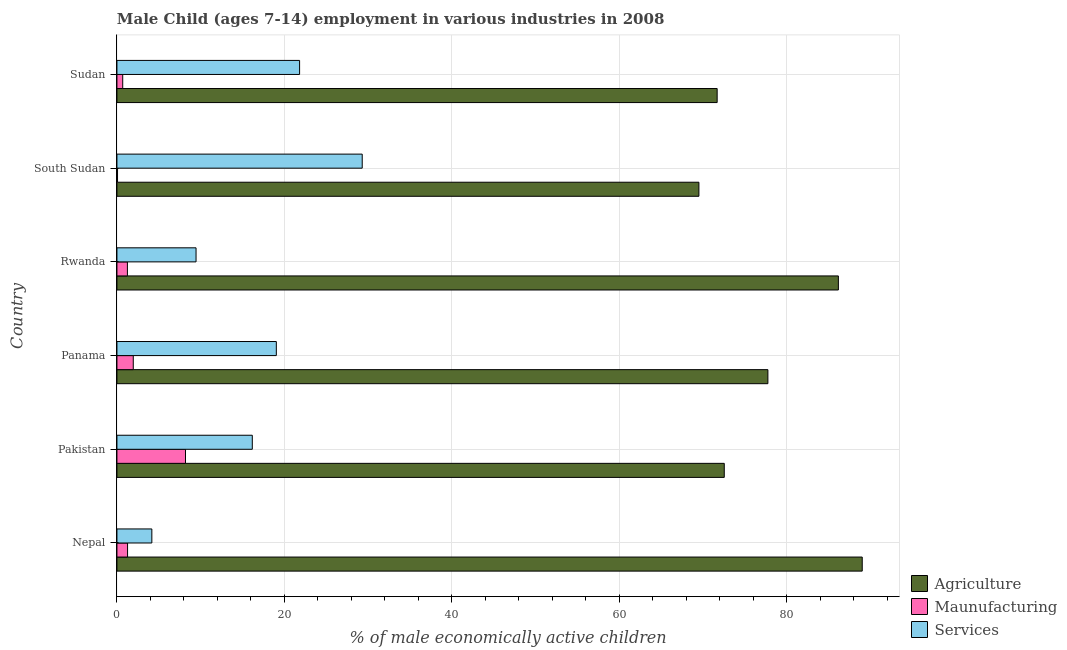How many different coloured bars are there?
Offer a terse response. 3. Are the number of bars on each tick of the Y-axis equal?
Provide a short and direct response. Yes. How many bars are there on the 5th tick from the top?
Your answer should be compact. 3. How many bars are there on the 6th tick from the bottom?
Make the answer very short. 3. What is the label of the 2nd group of bars from the top?
Your response must be concise. South Sudan. In how many cases, is the number of bars for a given country not equal to the number of legend labels?
Provide a succinct answer. 0. What is the percentage of economically active children in services in Rwanda?
Keep it short and to the point. 9.45. Across all countries, what is the maximum percentage of economically active children in services?
Offer a terse response. 29.3. Across all countries, what is the minimum percentage of economically active children in services?
Your answer should be very brief. 4.17. In which country was the percentage of economically active children in services maximum?
Provide a succinct answer. South Sudan. In which country was the percentage of economically active children in services minimum?
Keep it short and to the point. Nepal. What is the total percentage of economically active children in manufacturing in the graph?
Offer a very short reply. 13.42. What is the difference between the percentage of economically active children in manufacturing in Pakistan and that in Panama?
Offer a very short reply. 6.24. What is the difference between the percentage of economically active children in manufacturing in Sudan and the percentage of economically active children in agriculture in South Sudan?
Your response must be concise. -68.83. What is the average percentage of economically active children in services per country?
Your answer should be very brief. 16.66. What is the difference between the percentage of economically active children in manufacturing and percentage of economically active children in services in Sudan?
Give a very brief answer. -21.13. What is the ratio of the percentage of economically active children in manufacturing in Nepal to that in South Sudan?
Offer a very short reply. 18.14. Is the percentage of economically active children in manufacturing in Pakistan less than that in South Sudan?
Provide a short and direct response. No. What is the difference between the highest and the second highest percentage of economically active children in services?
Provide a short and direct response. 7.48. What is the difference between the highest and the lowest percentage of economically active children in agriculture?
Your answer should be compact. 19.51. In how many countries, is the percentage of economically active children in manufacturing greater than the average percentage of economically active children in manufacturing taken over all countries?
Your answer should be compact. 1. What does the 3rd bar from the top in Nepal represents?
Offer a terse response. Agriculture. What does the 3rd bar from the bottom in Rwanda represents?
Provide a succinct answer. Services. Is it the case that in every country, the sum of the percentage of economically active children in agriculture and percentage of economically active children in manufacturing is greater than the percentage of economically active children in services?
Your response must be concise. Yes. How many bars are there?
Your response must be concise. 18. How many countries are there in the graph?
Provide a short and direct response. 6. Are the values on the major ticks of X-axis written in scientific E-notation?
Your response must be concise. No. Does the graph contain any zero values?
Make the answer very short. No. How many legend labels are there?
Provide a short and direct response. 3. How are the legend labels stacked?
Provide a short and direct response. Vertical. What is the title of the graph?
Your answer should be very brief. Male Child (ages 7-14) employment in various industries in 2008. Does "Tertiary" appear as one of the legend labels in the graph?
Keep it short and to the point. No. What is the label or title of the X-axis?
Ensure brevity in your answer.  % of male economically active children. What is the label or title of the Y-axis?
Your answer should be compact. Country. What is the % of male economically active children in Agriculture in Nepal?
Ensure brevity in your answer.  89.03. What is the % of male economically active children of Maunufacturing in Nepal?
Give a very brief answer. 1.27. What is the % of male economically active children of Services in Nepal?
Offer a very short reply. 4.17. What is the % of male economically active children of Agriculture in Pakistan?
Give a very brief answer. 72.55. What is the % of male economically active children in Maunufacturing in Pakistan?
Make the answer very short. 8.19. What is the % of male economically active children of Services in Pakistan?
Offer a terse response. 16.17. What is the % of male economically active children of Agriculture in Panama?
Ensure brevity in your answer.  77.76. What is the % of male economically active children in Maunufacturing in Panama?
Keep it short and to the point. 1.95. What is the % of male economically active children in Services in Panama?
Offer a very short reply. 19.04. What is the % of male economically active children of Agriculture in Rwanda?
Offer a terse response. 86.18. What is the % of male economically active children in Services in Rwanda?
Provide a succinct answer. 9.45. What is the % of male economically active children in Agriculture in South Sudan?
Give a very brief answer. 69.52. What is the % of male economically active children of Maunufacturing in South Sudan?
Your answer should be very brief. 0.07. What is the % of male economically active children of Services in South Sudan?
Your answer should be very brief. 29.3. What is the % of male economically active children of Agriculture in Sudan?
Your answer should be very brief. 71.7. What is the % of male economically active children in Maunufacturing in Sudan?
Keep it short and to the point. 0.69. What is the % of male economically active children in Services in Sudan?
Offer a terse response. 21.82. Across all countries, what is the maximum % of male economically active children of Agriculture?
Your answer should be very brief. 89.03. Across all countries, what is the maximum % of male economically active children of Maunufacturing?
Make the answer very short. 8.19. Across all countries, what is the maximum % of male economically active children of Services?
Provide a succinct answer. 29.3. Across all countries, what is the minimum % of male economically active children of Agriculture?
Offer a very short reply. 69.52. Across all countries, what is the minimum % of male economically active children of Maunufacturing?
Give a very brief answer. 0.07. Across all countries, what is the minimum % of male economically active children in Services?
Your response must be concise. 4.17. What is the total % of male economically active children of Agriculture in the graph?
Your answer should be compact. 466.74. What is the total % of male economically active children in Maunufacturing in the graph?
Ensure brevity in your answer.  13.42. What is the total % of male economically active children of Services in the graph?
Offer a terse response. 99.95. What is the difference between the % of male economically active children in Agriculture in Nepal and that in Pakistan?
Provide a short and direct response. 16.48. What is the difference between the % of male economically active children in Maunufacturing in Nepal and that in Pakistan?
Provide a succinct answer. -6.92. What is the difference between the % of male economically active children of Services in Nepal and that in Pakistan?
Ensure brevity in your answer.  -12. What is the difference between the % of male economically active children in Agriculture in Nepal and that in Panama?
Make the answer very short. 11.27. What is the difference between the % of male economically active children in Maunufacturing in Nepal and that in Panama?
Make the answer very short. -0.68. What is the difference between the % of male economically active children in Services in Nepal and that in Panama?
Your response must be concise. -14.87. What is the difference between the % of male economically active children of Agriculture in Nepal and that in Rwanda?
Make the answer very short. 2.85. What is the difference between the % of male economically active children in Maunufacturing in Nepal and that in Rwanda?
Your answer should be very brief. 0.02. What is the difference between the % of male economically active children in Services in Nepal and that in Rwanda?
Your answer should be compact. -5.28. What is the difference between the % of male economically active children of Agriculture in Nepal and that in South Sudan?
Your answer should be very brief. 19.51. What is the difference between the % of male economically active children in Maunufacturing in Nepal and that in South Sudan?
Offer a terse response. 1.2. What is the difference between the % of male economically active children in Services in Nepal and that in South Sudan?
Provide a succinct answer. -25.13. What is the difference between the % of male economically active children of Agriculture in Nepal and that in Sudan?
Keep it short and to the point. 17.33. What is the difference between the % of male economically active children of Maunufacturing in Nepal and that in Sudan?
Your response must be concise. 0.58. What is the difference between the % of male economically active children of Services in Nepal and that in Sudan?
Offer a very short reply. -17.65. What is the difference between the % of male economically active children in Agriculture in Pakistan and that in Panama?
Ensure brevity in your answer.  -5.21. What is the difference between the % of male economically active children of Maunufacturing in Pakistan and that in Panama?
Make the answer very short. 6.24. What is the difference between the % of male economically active children of Services in Pakistan and that in Panama?
Your response must be concise. -2.87. What is the difference between the % of male economically active children of Agriculture in Pakistan and that in Rwanda?
Provide a succinct answer. -13.63. What is the difference between the % of male economically active children in Maunufacturing in Pakistan and that in Rwanda?
Your response must be concise. 6.94. What is the difference between the % of male economically active children of Services in Pakistan and that in Rwanda?
Offer a terse response. 6.72. What is the difference between the % of male economically active children in Agriculture in Pakistan and that in South Sudan?
Your response must be concise. 3.03. What is the difference between the % of male economically active children of Maunufacturing in Pakistan and that in South Sudan?
Offer a very short reply. 8.12. What is the difference between the % of male economically active children in Services in Pakistan and that in South Sudan?
Ensure brevity in your answer.  -13.13. What is the difference between the % of male economically active children of Agriculture in Pakistan and that in Sudan?
Provide a succinct answer. 0.85. What is the difference between the % of male economically active children in Services in Pakistan and that in Sudan?
Offer a very short reply. -5.65. What is the difference between the % of male economically active children of Agriculture in Panama and that in Rwanda?
Your response must be concise. -8.42. What is the difference between the % of male economically active children in Maunufacturing in Panama and that in Rwanda?
Make the answer very short. 0.7. What is the difference between the % of male economically active children of Services in Panama and that in Rwanda?
Give a very brief answer. 9.59. What is the difference between the % of male economically active children in Agriculture in Panama and that in South Sudan?
Offer a very short reply. 8.24. What is the difference between the % of male economically active children in Maunufacturing in Panama and that in South Sudan?
Your answer should be compact. 1.88. What is the difference between the % of male economically active children of Services in Panama and that in South Sudan?
Make the answer very short. -10.26. What is the difference between the % of male economically active children of Agriculture in Panama and that in Sudan?
Give a very brief answer. 6.06. What is the difference between the % of male economically active children in Maunufacturing in Panama and that in Sudan?
Keep it short and to the point. 1.26. What is the difference between the % of male economically active children in Services in Panama and that in Sudan?
Keep it short and to the point. -2.78. What is the difference between the % of male economically active children of Agriculture in Rwanda and that in South Sudan?
Your answer should be compact. 16.66. What is the difference between the % of male economically active children of Maunufacturing in Rwanda and that in South Sudan?
Provide a short and direct response. 1.18. What is the difference between the % of male economically active children of Services in Rwanda and that in South Sudan?
Provide a short and direct response. -19.85. What is the difference between the % of male economically active children in Agriculture in Rwanda and that in Sudan?
Provide a short and direct response. 14.48. What is the difference between the % of male economically active children in Maunufacturing in Rwanda and that in Sudan?
Give a very brief answer. 0.56. What is the difference between the % of male economically active children in Services in Rwanda and that in Sudan?
Give a very brief answer. -12.37. What is the difference between the % of male economically active children of Agriculture in South Sudan and that in Sudan?
Make the answer very short. -2.18. What is the difference between the % of male economically active children in Maunufacturing in South Sudan and that in Sudan?
Offer a very short reply. -0.62. What is the difference between the % of male economically active children of Services in South Sudan and that in Sudan?
Provide a short and direct response. 7.48. What is the difference between the % of male economically active children in Agriculture in Nepal and the % of male economically active children in Maunufacturing in Pakistan?
Make the answer very short. 80.84. What is the difference between the % of male economically active children of Agriculture in Nepal and the % of male economically active children of Services in Pakistan?
Give a very brief answer. 72.86. What is the difference between the % of male economically active children in Maunufacturing in Nepal and the % of male economically active children in Services in Pakistan?
Your answer should be compact. -14.9. What is the difference between the % of male economically active children of Agriculture in Nepal and the % of male economically active children of Maunufacturing in Panama?
Offer a terse response. 87.08. What is the difference between the % of male economically active children in Agriculture in Nepal and the % of male economically active children in Services in Panama?
Offer a terse response. 69.99. What is the difference between the % of male economically active children in Maunufacturing in Nepal and the % of male economically active children in Services in Panama?
Offer a terse response. -17.77. What is the difference between the % of male economically active children in Agriculture in Nepal and the % of male economically active children in Maunufacturing in Rwanda?
Offer a very short reply. 87.78. What is the difference between the % of male economically active children in Agriculture in Nepal and the % of male economically active children in Services in Rwanda?
Offer a terse response. 79.58. What is the difference between the % of male economically active children of Maunufacturing in Nepal and the % of male economically active children of Services in Rwanda?
Provide a short and direct response. -8.18. What is the difference between the % of male economically active children in Agriculture in Nepal and the % of male economically active children in Maunufacturing in South Sudan?
Keep it short and to the point. 88.96. What is the difference between the % of male economically active children of Agriculture in Nepal and the % of male economically active children of Services in South Sudan?
Provide a succinct answer. 59.73. What is the difference between the % of male economically active children in Maunufacturing in Nepal and the % of male economically active children in Services in South Sudan?
Make the answer very short. -28.03. What is the difference between the % of male economically active children in Agriculture in Nepal and the % of male economically active children in Maunufacturing in Sudan?
Provide a succinct answer. 88.34. What is the difference between the % of male economically active children of Agriculture in Nepal and the % of male economically active children of Services in Sudan?
Offer a very short reply. 67.21. What is the difference between the % of male economically active children of Maunufacturing in Nepal and the % of male economically active children of Services in Sudan?
Keep it short and to the point. -20.55. What is the difference between the % of male economically active children in Agriculture in Pakistan and the % of male economically active children in Maunufacturing in Panama?
Offer a terse response. 70.6. What is the difference between the % of male economically active children in Agriculture in Pakistan and the % of male economically active children in Services in Panama?
Give a very brief answer. 53.51. What is the difference between the % of male economically active children of Maunufacturing in Pakistan and the % of male economically active children of Services in Panama?
Your answer should be very brief. -10.85. What is the difference between the % of male economically active children in Agriculture in Pakistan and the % of male economically active children in Maunufacturing in Rwanda?
Provide a short and direct response. 71.3. What is the difference between the % of male economically active children of Agriculture in Pakistan and the % of male economically active children of Services in Rwanda?
Give a very brief answer. 63.1. What is the difference between the % of male economically active children of Maunufacturing in Pakistan and the % of male economically active children of Services in Rwanda?
Your response must be concise. -1.26. What is the difference between the % of male economically active children of Agriculture in Pakistan and the % of male economically active children of Maunufacturing in South Sudan?
Your answer should be compact. 72.48. What is the difference between the % of male economically active children in Agriculture in Pakistan and the % of male economically active children in Services in South Sudan?
Give a very brief answer. 43.25. What is the difference between the % of male economically active children in Maunufacturing in Pakistan and the % of male economically active children in Services in South Sudan?
Ensure brevity in your answer.  -21.11. What is the difference between the % of male economically active children of Agriculture in Pakistan and the % of male economically active children of Maunufacturing in Sudan?
Provide a succinct answer. 71.86. What is the difference between the % of male economically active children in Agriculture in Pakistan and the % of male economically active children in Services in Sudan?
Ensure brevity in your answer.  50.73. What is the difference between the % of male economically active children of Maunufacturing in Pakistan and the % of male economically active children of Services in Sudan?
Ensure brevity in your answer.  -13.63. What is the difference between the % of male economically active children of Agriculture in Panama and the % of male economically active children of Maunufacturing in Rwanda?
Give a very brief answer. 76.51. What is the difference between the % of male economically active children in Agriculture in Panama and the % of male economically active children in Services in Rwanda?
Offer a very short reply. 68.31. What is the difference between the % of male economically active children of Agriculture in Panama and the % of male economically active children of Maunufacturing in South Sudan?
Offer a very short reply. 77.69. What is the difference between the % of male economically active children of Agriculture in Panama and the % of male economically active children of Services in South Sudan?
Give a very brief answer. 48.46. What is the difference between the % of male economically active children in Maunufacturing in Panama and the % of male economically active children in Services in South Sudan?
Give a very brief answer. -27.35. What is the difference between the % of male economically active children in Agriculture in Panama and the % of male economically active children in Maunufacturing in Sudan?
Keep it short and to the point. 77.07. What is the difference between the % of male economically active children of Agriculture in Panama and the % of male economically active children of Services in Sudan?
Make the answer very short. 55.94. What is the difference between the % of male economically active children of Maunufacturing in Panama and the % of male economically active children of Services in Sudan?
Give a very brief answer. -19.87. What is the difference between the % of male economically active children of Agriculture in Rwanda and the % of male economically active children of Maunufacturing in South Sudan?
Your answer should be very brief. 86.11. What is the difference between the % of male economically active children in Agriculture in Rwanda and the % of male economically active children in Services in South Sudan?
Keep it short and to the point. 56.88. What is the difference between the % of male economically active children of Maunufacturing in Rwanda and the % of male economically active children of Services in South Sudan?
Your response must be concise. -28.05. What is the difference between the % of male economically active children in Agriculture in Rwanda and the % of male economically active children in Maunufacturing in Sudan?
Provide a succinct answer. 85.49. What is the difference between the % of male economically active children of Agriculture in Rwanda and the % of male economically active children of Services in Sudan?
Provide a succinct answer. 64.36. What is the difference between the % of male economically active children in Maunufacturing in Rwanda and the % of male economically active children in Services in Sudan?
Provide a succinct answer. -20.57. What is the difference between the % of male economically active children in Agriculture in South Sudan and the % of male economically active children in Maunufacturing in Sudan?
Ensure brevity in your answer.  68.83. What is the difference between the % of male economically active children in Agriculture in South Sudan and the % of male economically active children in Services in Sudan?
Offer a very short reply. 47.7. What is the difference between the % of male economically active children in Maunufacturing in South Sudan and the % of male economically active children in Services in Sudan?
Your answer should be compact. -21.75. What is the average % of male economically active children of Agriculture per country?
Ensure brevity in your answer.  77.79. What is the average % of male economically active children of Maunufacturing per country?
Your answer should be very brief. 2.24. What is the average % of male economically active children of Services per country?
Ensure brevity in your answer.  16.66. What is the difference between the % of male economically active children in Agriculture and % of male economically active children in Maunufacturing in Nepal?
Make the answer very short. 87.76. What is the difference between the % of male economically active children in Agriculture and % of male economically active children in Services in Nepal?
Keep it short and to the point. 84.86. What is the difference between the % of male economically active children of Maunufacturing and % of male economically active children of Services in Nepal?
Your answer should be very brief. -2.9. What is the difference between the % of male economically active children of Agriculture and % of male economically active children of Maunufacturing in Pakistan?
Your answer should be very brief. 64.36. What is the difference between the % of male economically active children in Agriculture and % of male economically active children in Services in Pakistan?
Your answer should be compact. 56.38. What is the difference between the % of male economically active children of Maunufacturing and % of male economically active children of Services in Pakistan?
Your answer should be very brief. -7.98. What is the difference between the % of male economically active children in Agriculture and % of male economically active children in Maunufacturing in Panama?
Offer a very short reply. 75.81. What is the difference between the % of male economically active children of Agriculture and % of male economically active children of Services in Panama?
Your answer should be compact. 58.72. What is the difference between the % of male economically active children in Maunufacturing and % of male economically active children in Services in Panama?
Make the answer very short. -17.09. What is the difference between the % of male economically active children in Agriculture and % of male economically active children in Maunufacturing in Rwanda?
Keep it short and to the point. 84.93. What is the difference between the % of male economically active children of Agriculture and % of male economically active children of Services in Rwanda?
Make the answer very short. 76.73. What is the difference between the % of male economically active children in Agriculture and % of male economically active children in Maunufacturing in South Sudan?
Your answer should be compact. 69.45. What is the difference between the % of male economically active children in Agriculture and % of male economically active children in Services in South Sudan?
Ensure brevity in your answer.  40.22. What is the difference between the % of male economically active children in Maunufacturing and % of male economically active children in Services in South Sudan?
Give a very brief answer. -29.23. What is the difference between the % of male economically active children in Agriculture and % of male economically active children in Maunufacturing in Sudan?
Give a very brief answer. 71.01. What is the difference between the % of male economically active children in Agriculture and % of male economically active children in Services in Sudan?
Your response must be concise. 49.88. What is the difference between the % of male economically active children of Maunufacturing and % of male economically active children of Services in Sudan?
Your answer should be very brief. -21.13. What is the ratio of the % of male economically active children of Agriculture in Nepal to that in Pakistan?
Offer a terse response. 1.23. What is the ratio of the % of male economically active children of Maunufacturing in Nepal to that in Pakistan?
Give a very brief answer. 0.16. What is the ratio of the % of male economically active children in Services in Nepal to that in Pakistan?
Your answer should be very brief. 0.26. What is the ratio of the % of male economically active children of Agriculture in Nepal to that in Panama?
Your response must be concise. 1.14. What is the ratio of the % of male economically active children in Maunufacturing in Nepal to that in Panama?
Your answer should be compact. 0.65. What is the ratio of the % of male economically active children in Services in Nepal to that in Panama?
Your response must be concise. 0.22. What is the ratio of the % of male economically active children in Agriculture in Nepal to that in Rwanda?
Give a very brief answer. 1.03. What is the ratio of the % of male economically active children of Maunufacturing in Nepal to that in Rwanda?
Your answer should be very brief. 1.02. What is the ratio of the % of male economically active children in Services in Nepal to that in Rwanda?
Your response must be concise. 0.44. What is the ratio of the % of male economically active children of Agriculture in Nepal to that in South Sudan?
Give a very brief answer. 1.28. What is the ratio of the % of male economically active children of Maunufacturing in Nepal to that in South Sudan?
Your response must be concise. 18.14. What is the ratio of the % of male economically active children of Services in Nepal to that in South Sudan?
Provide a short and direct response. 0.14. What is the ratio of the % of male economically active children in Agriculture in Nepal to that in Sudan?
Offer a very short reply. 1.24. What is the ratio of the % of male economically active children of Maunufacturing in Nepal to that in Sudan?
Offer a very short reply. 1.84. What is the ratio of the % of male economically active children in Services in Nepal to that in Sudan?
Keep it short and to the point. 0.19. What is the ratio of the % of male economically active children in Agriculture in Pakistan to that in Panama?
Provide a short and direct response. 0.93. What is the ratio of the % of male economically active children in Services in Pakistan to that in Panama?
Offer a very short reply. 0.85. What is the ratio of the % of male economically active children in Agriculture in Pakistan to that in Rwanda?
Your answer should be very brief. 0.84. What is the ratio of the % of male economically active children in Maunufacturing in Pakistan to that in Rwanda?
Provide a short and direct response. 6.55. What is the ratio of the % of male economically active children of Services in Pakistan to that in Rwanda?
Provide a succinct answer. 1.71. What is the ratio of the % of male economically active children of Agriculture in Pakistan to that in South Sudan?
Your answer should be very brief. 1.04. What is the ratio of the % of male economically active children in Maunufacturing in Pakistan to that in South Sudan?
Ensure brevity in your answer.  117. What is the ratio of the % of male economically active children in Services in Pakistan to that in South Sudan?
Make the answer very short. 0.55. What is the ratio of the % of male economically active children of Agriculture in Pakistan to that in Sudan?
Your answer should be very brief. 1.01. What is the ratio of the % of male economically active children in Maunufacturing in Pakistan to that in Sudan?
Offer a terse response. 11.87. What is the ratio of the % of male economically active children of Services in Pakistan to that in Sudan?
Ensure brevity in your answer.  0.74. What is the ratio of the % of male economically active children in Agriculture in Panama to that in Rwanda?
Offer a terse response. 0.9. What is the ratio of the % of male economically active children in Maunufacturing in Panama to that in Rwanda?
Give a very brief answer. 1.56. What is the ratio of the % of male economically active children of Services in Panama to that in Rwanda?
Keep it short and to the point. 2.01. What is the ratio of the % of male economically active children of Agriculture in Panama to that in South Sudan?
Offer a very short reply. 1.12. What is the ratio of the % of male economically active children of Maunufacturing in Panama to that in South Sudan?
Offer a very short reply. 27.86. What is the ratio of the % of male economically active children of Services in Panama to that in South Sudan?
Provide a succinct answer. 0.65. What is the ratio of the % of male economically active children in Agriculture in Panama to that in Sudan?
Keep it short and to the point. 1.08. What is the ratio of the % of male economically active children in Maunufacturing in Panama to that in Sudan?
Your response must be concise. 2.83. What is the ratio of the % of male economically active children of Services in Panama to that in Sudan?
Provide a succinct answer. 0.87. What is the ratio of the % of male economically active children in Agriculture in Rwanda to that in South Sudan?
Give a very brief answer. 1.24. What is the ratio of the % of male economically active children of Maunufacturing in Rwanda to that in South Sudan?
Provide a short and direct response. 17.86. What is the ratio of the % of male economically active children of Services in Rwanda to that in South Sudan?
Ensure brevity in your answer.  0.32. What is the ratio of the % of male economically active children of Agriculture in Rwanda to that in Sudan?
Keep it short and to the point. 1.2. What is the ratio of the % of male economically active children in Maunufacturing in Rwanda to that in Sudan?
Provide a succinct answer. 1.81. What is the ratio of the % of male economically active children in Services in Rwanda to that in Sudan?
Ensure brevity in your answer.  0.43. What is the ratio of the % of male economically active children in Agriculture in South Sudan to that in Sudan?
Give a very brief answer. 0.97. What is the ratio of the % of male economically active children of Maunufacturing in South Sudan to that in Sudan?
Provide a succinct answer. 0.1. What is the ratio of the % of male economically active children in Services in South Sudan to that in Sudan?
Your answer should be very brief. 1.34. What is the difference between the highest and the second highest % of male economically active children of Agriculture?
Offer a very short reply. 2.85. What is the difference between the highest and the second highest % of male economically active children of Maunufacturing?
Offer a very short reply. 6.24. What is the difference between the highest and the second highest % of male economically active children of Services?
Your answer should be very brief. 7.48. What is the difference between the highest and the lowest % of male economically active children of Agriculture?
Provide a succinct answer. 19.51. What is the difference between the highest and the lowest % of male economically active children in Maunufacturing?
Offer a terse response. 8.12. What is the difference between the highest and the lowest % of male economically active children of Services?
Provide a succinct answer. 25.13. 